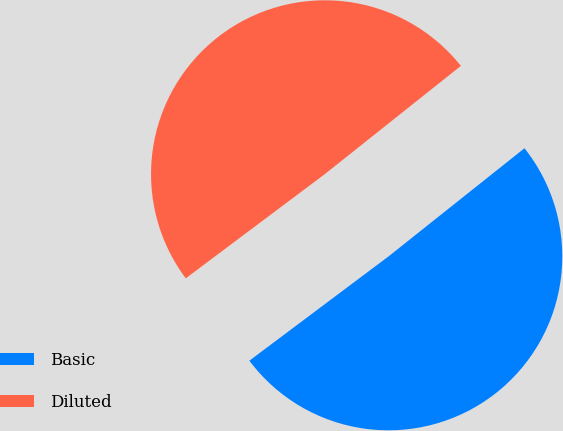Convert chart to OTSL. <chart><loc_0><loc_0><loc_500><loc_500><pie_chart><fcel>Basic<fcel>Diluted<nl><fcel>50.46%<fcel>49.54%<nl></chart> 